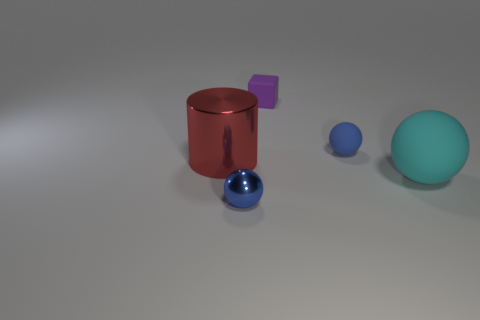Is the small shiny object the same color as the small rubber ball?
Keep it short and to the point. Yes. There is a cyan ball that is the same material as the purple thing; what is its size?
Your response must be concise. Large. How many cyan things have the same shape as the purple rubber object?
Your response must be concise. 0. How many objects are tiny purple rubber cubes that are behind the large rubber ball or small blue balls that are right of the small blue metal object?
Provide a short and direct response. 2. What number of small shiny spheres are on the right side of the tiny ball right of the shiny ball?
Your answer should be very brief. 0. There is a blue object that is in front of the big red metal thing; is its shape the same as the big object that is to the left of the tiny purple block?
Offer a very short reply. No. The thing that is the same color as the metallic ball is what shape?
Offer a terse response. Sphere. Is there a small object made of the same material as the tiny purple block?
Your response must be concise. Yes. How many metal objects are tiny cubes or tiny things?
Your answer should be compact. 1. There is a small purple object that is to the right of the big object that is on the left side of the large ball; what is its shape?
Your answer should be compact. Cube. 